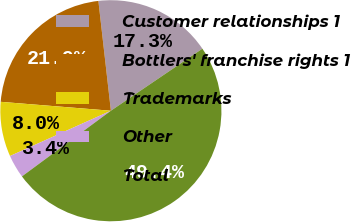Convert chart. <chart><loc_0><loc_0><loc_500><loc_500><pie_chart><fcel>Customer relationships 1<fcel>Bottlers' franchise rights 1<fcel>Trademarks<fcel>Other<fcel>Total<nl><fcel>17.32%<fcel>21.91%<fcel>8.0%<fcel>3.41%<fcel>49.36%<nl></chart> 